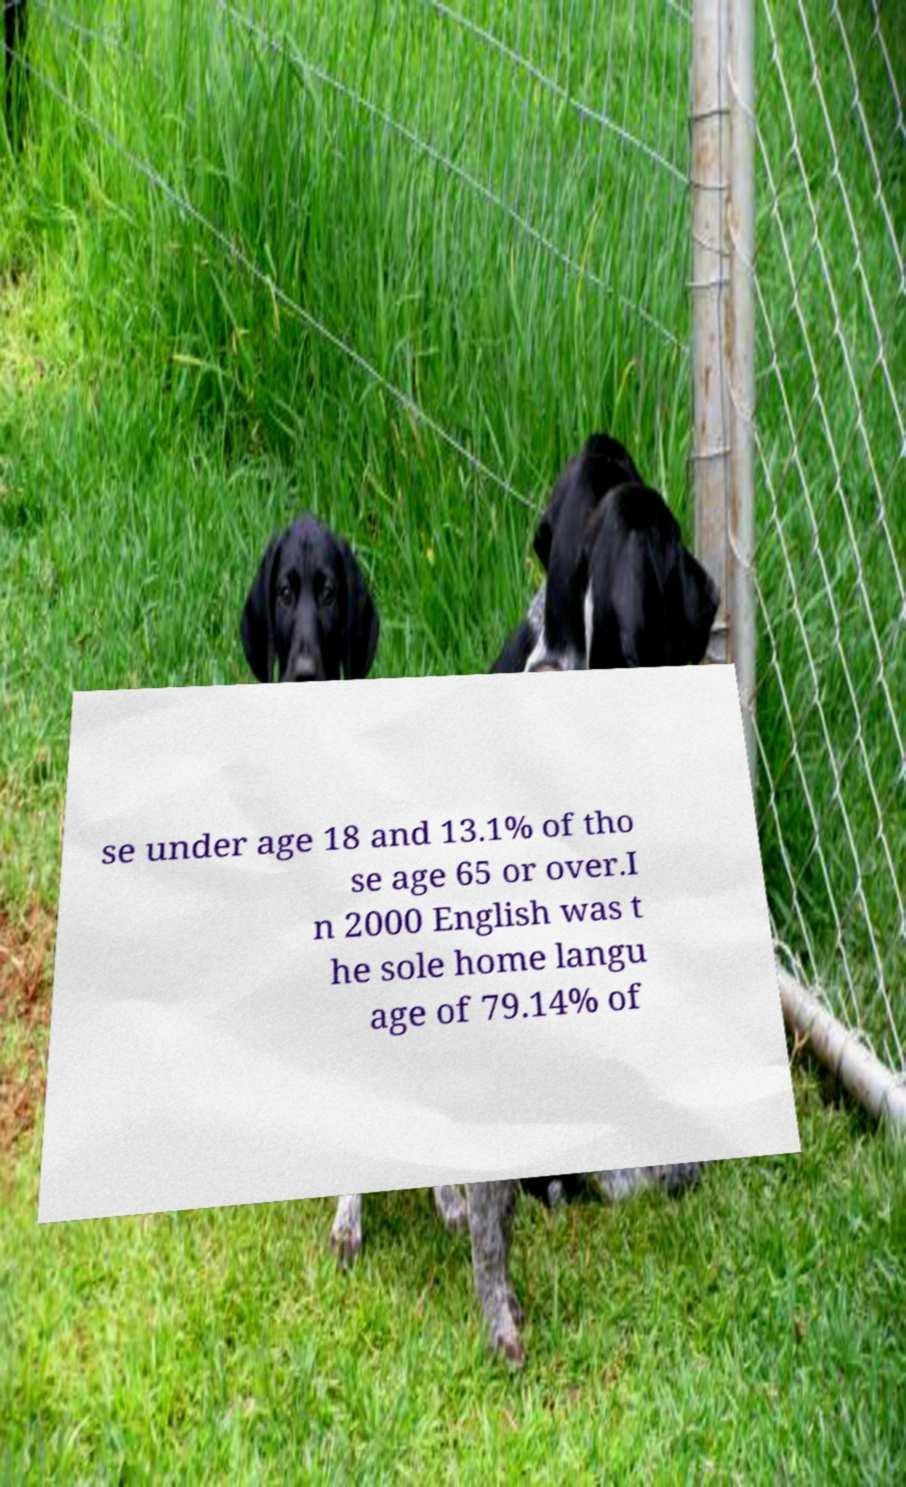Please read and relay the text visible in this image. What does it say? se under age 18 and 13.1% of tho se age 65 or over.I n 2000 English was t he sole home langu age of 79.14% of 